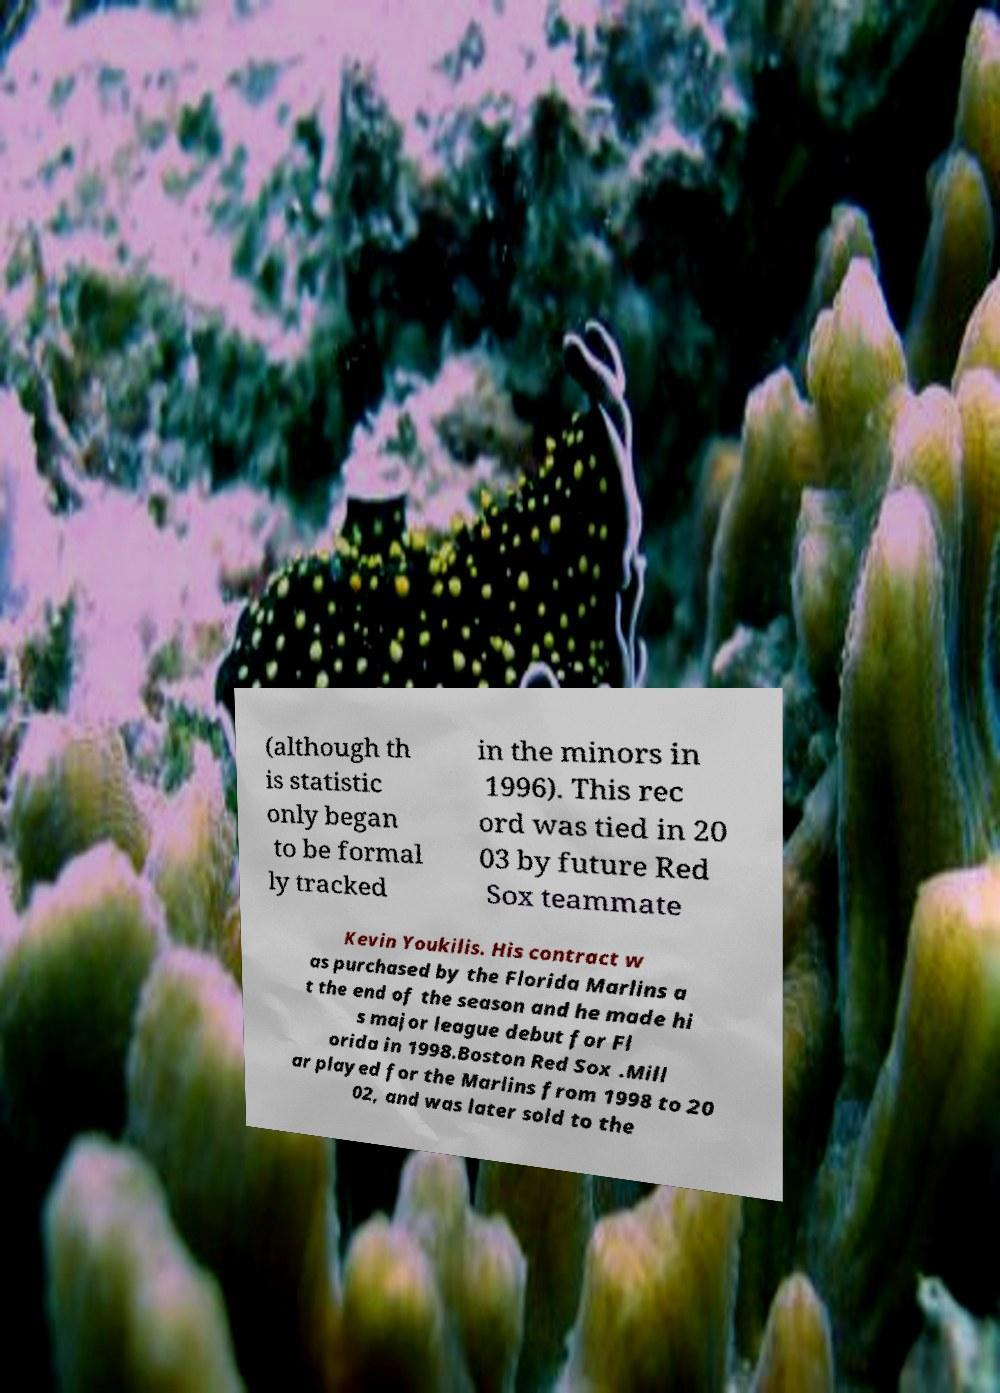What messages or text are displayed in this image? I need them in a readable, typed format. (although th is statistic only began to be formal ly tracked in the minors in 1996). This rec ord was tied in 20 03 by future Red Sox teammate Kevin Youkilis. His contract w as purchased by the Florida Marlins a t the end of the season and he made hi s major league debut for Fl orida in 1998.Boston Red Sox .Mill ar played for the Marlins from 1998 to 20 02, and was later sold to the 